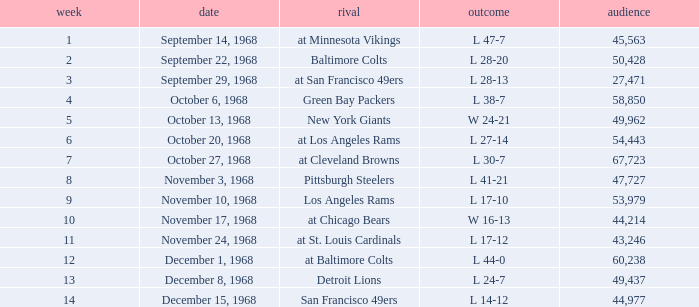Which Attendance has an Opponent of new york giants, and a Week smaller than 5? None. 